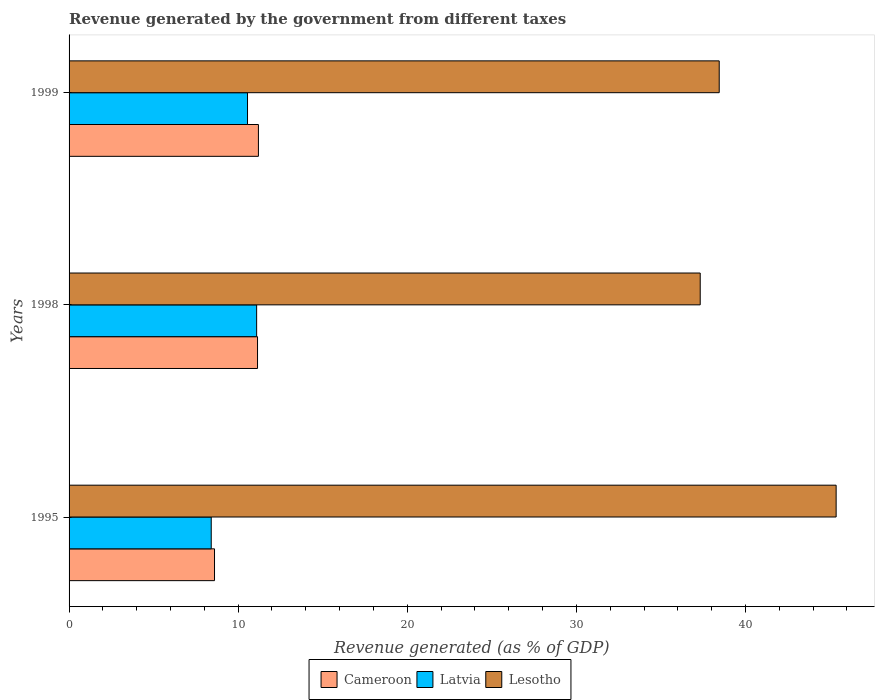How many groups of bars are there?
Keep it short and to the point. 3. Are the number of bars per tick equal to the number of legend labels?
Provide a succinct answer. Yes. Are the number of bars on each tick of the Y-axis equal?
Provide a short and direct response. Yes. How many bars are there on the 2nd tick from the bottom?
Ensure brevity in your answer.  3. What is the label of the 3rd group of bars from the top?
Provide a short and direct response. 1995. In how many cases, is the number of bars for a given year not equal to the number of legend labels?
Give a very brief answer. 0. What is the revenue generated by the government in Latvia in 1998?
Your answer should be compact. 11.09. Across all years, what is the maximum revenue generated by the government in Lesotho?
Keep it short and to the point. 45.36. Across all years, what is the minimum revenue generated by the government in Lesotho?
Offer a very short reply. 37.32. What is the total revenue generated by the government in Cameroon in the graph?
Make the answer very short. 30.94. What is the difference between the revenue generated by the government in Latvia in 1995 and that in 1998?
Your response must be concise. -2.69. What is the difference between the revenue generated by the government in Cameroon in 1995 and the revenue generated by the government in Latvia in 1999?
Provide a succinct answer. -1.95. What is the average revenue generated by the government in Lesotho per year?
Provide a succinct answer. 40.38. In the year 1995, what is the difference between the revenue generated by the government in Cameroon and revenue generated by the government in Lesotho?
Offer a terse response. -36.76. What is the ratio of the revenue generated by the government in Latvia in 1998 to that in 1999?
Your answer should be very brief. 1.05. Is the difference between the revenue generated by the government in Cameroon in 1995 and 1999 greater than the difference between the revenue generated by the government in Lesotho in 1995 and 1999?
Your response must be concise. No. What is the difference between the highest and the second highest revenue generated by the government in Latvia?
Provide a short and direct response. 0.54. What is the difference between the highest and the lowest revenue generated by the government in Latvia?
Keep it short and to the point. 2.69. In how many years, is the revenue generated by the government in Latvia greater than the average revenue generated by the government in Latvia taken over all years?
Provide a short and direct response. 2. Is the sum of the revenue generated by the government in Lesotho in 1995 and 1998 greater than the maximum revenue generated by the government in Latvia across all years?
Keep it short and to the point. Yes. What does the 1st bar from the top in 1998 represents?
Give a very brief answer. Lesotho. What does the 3rd bar from the bottom in 1995 represents?
Your answer should be very brief. Lesotho. How many bars are there?
Ensure brevity in your answer.  9. Are the values on the major ticks of X-axis written in scientific E-notation?
Your answer should be very brief. No. Does the graph contain grids?
Keep it short and to the point. No. Where does the legend appear in the graph?
Your answer should be very brief. Bottom center. How many legend labels are there?
Provide a short and direct response. 3. How are the legend labels stacked?
Provide a succinct answer. Horizontal. What is the title of the graph?
Offer a terse response. Revenue generated by the government from different taxes. Does "Sub-Saharan Africa (all income levels)" appear as one of the legend labels in the graph?
Offer a very short reply. No. What is the label or title of the X-axis?
Give a very brief answer. Revenue generated (as % of GDP). What is the Revenue generated (as % of GDP) in Cameroon in 1995?
Your answer should be very brief. 8.6. What is the Revenue generated (as % of GDP) in Latvia in 1995?
Provide a short and direct response. 8.41. What is the Revenue generated (as % of GDP) in Lesotho in 1995?
Your response must be concise. 45.36. What is the Revenue generated (as % of GDP) in Cameroon in 1998?
Your response must be concise. 11.15. What is the Revenue generated (as % of GDP) in Latvia in 1998?
Give a very brief answer. 11.09. What is the Revenue generated (as % of GDP) in Lesotho in 1998?
Your answer should be compact. 37.32. What is the Revenue generated (as % of GDP) in Cameroon in 1999?
Make the answer very short. 11.2. What is the Revenue generated (as % of GDP) of Latvia in 1999?
Ensure brevity in your answer.  10.55. What is the Revenue generated (as % of GDP) of Lesotho in 1999?
Keep it short and to the point. 38.45. Across all years, what is the maximum Revenue generated (as % of GDP) in Cameroon?
Offer a very short reply. 11.2. Across all years, what is the maximum Revenue generated (as % of GDP) in Latvia?
Give a very brief answer. 11.09. Across all years, what is the maximum Revenue generated (as % of GDP) in Lesotho?
Keep it short and to the point. 45.36. Across all years, what is the minimum Revenue generated (as % of GDP) in Cameroon?
Your answer should be compact. 8.6. Across all years, what is the minimum Revenue generated (as % of GDP) of Latvia?
Provide a short and direct response. 8.41. Across all years, what is the minimum Revenue generated (as % of GDP) in Lesotho?
Your answer should be compact. 37.32. What is the total Revenue generated (as % of GDP) of Cameroon in the graph?
Your answer should be compact. 30.94. What is the total Revenue generated (as % of GDP) in Latvia in the graph?
Provide a short and direct response. 30.05. What is the total Revenue generated (as % of GDP) of Lesotho in the graph?
Provide a succinct answer. 121.14. What is the difference between the Revenue generated (as % of GDP) in Cameroon in 1995 and that in 1998?
Offer a terse response. -2.54. What is the difference between the Revenue generated (as % of GDP) of Latvia in 1995 and that in 1998?
Ensure brevity in your answer.  -2.69. What is the difference between the Revenue generated (as % of GDP) in Lesotho in 1995 and that in 1998?
Keep it short and to the point. 8.04. What is the difference between the Revenue generated (as % of GDP) of Cameroon in 1995 and that in 1999?
Your answer should be very brief. -2.6. What is the difference between the Revenue generated (as % of GDP) of Latvia in 1995 and that in 1999?
Make the answer very short. -2.15. What is the difference between the Revenue generated (as % of GDP) of Lesotho in 1995 and that in 1999?
Your answer should be compact. 6.91. What is the difference between the Revenue generated (as % of GDP) of Cameroon in 1998 and that in 1999?
Your response must be concise. -0.05. What is the difference between the Revenue generated (as % of GDP) of Latvia in 1998 and that in 1999?
Make the answer very short. 0.54. What is the difference between the Revenue generated (as % of GDP) in Lesotho in 1998 and that in 1999?
Keep it short and to the point. -1.12. What is the difference between the Revenue generated (as % of GDP) of Cameroon in 1995 and the Revenue generated (as % of GDP) of Latvia in 1998?
Ensure brevity in your answer.  -2.49. What is the difference between the Revenue generated (as % of GDP) of Cameroon in 1995 and the Revenue generated (as % of GDP) of Lesotho in 1998?
Provide a short and direct response. -28.72. What is the difference between the Revenue generated (as % of GDP) of Latvia in 1995 and the Revenue generated (as % of GDP) of Lesotho in 1998?
Ensure brevity in your answer.  -28.92. What is the difference between the Revenue generated (as % of GDP) in Cameroon in 1995 and the Revenue generated (as % of GDP) in Latvia in 1999?
Make the answer very short. -1.95. What is the difference between the Revenue generated (as % of GDP) in Cameroon in 1995 and the Revenue generated (as % of GDP) in Lesotho in 1999?
Ensure brevity in your answer.  -29.85. What is the difference between the Revenue generated (as % of GDP) in Latvia in 1995 and the Revenue generated (as % of GDP) in Lesotho in 1999?
Your answer should be compact. -30.04. What is the difference between the Revenue generated (as % of GDP) in Cameroon in 1998 and the Revenue generated (as % of GDP) in Latvia in 1999?
Provide a short and direct response. 0.59. What is the difference between the Revenue generated (as % of GDP) in Cameroon in 1998 and the Revenue generated (as % of GDP) in Lesotho in 1999?
Your answer should be compact. -27.3. What is the difference between the Revenue generated (as % of GDP) of Latvia in 1998 and the Revenue generated (as % of GDP) of Lesotho in 1999?
Provide a succinct answer. -27.36. What is the average Revenue generated (as % of GDP) in Cameroon per year?
Make the answer very short. 10.31. What is the average Revenue generated (as % of GDP) in Latvia per year?
Make the answer very short. 10.02. What is the average Revenue generated (as % of GDP) of Lesotho per year?
Ensure brevity in your answer.  40.38. In the year 1995, what is the difference between the Revenue generated (as % of GDP) in Cameroon and Revenue generated (as % of GDP) in Latvia?
Provide a succinct answer. 0.19. In the year 1995, what is the difference between the Revenue generated (as % of GDP) in Cameroon and Revenue generated (as % of GDP) in Lesotho?
Provide a succinct answer. -36.76. In the year 1995, what is the difference between the Revenue generated (as % of GDP) in Latvia and Revenue generated (as % of GDP) in Lesotho?
Your answer should be compact. -36.96. In the year 1998, what is the difference between the Revenue generated (as % of GDP) in Cameroon and Revenue generated (as % of GDP) in Latvia?
Make the answer very short. 0.05. In the year 1998, what is the difference between the Revenue generated (as % of GDP) of Cameroon and Revenue generated (as % of GDP) of Lesotho?
Give a very brief answer. -26.18. In the year 1998, what is the difference between the Revenue generated (as % of GDP) of Latvia and Revenue generated (as % of GDP) of Lesotho?
Provide a succinct answer. -26.23. In the year 1999, what is the difference between the Revenue generated (as % of GDP) of Cameroon and Revenue generated (as % of GDP) of Latvia?
Keep it short and to the point. 0.65. In the year 1999, what is the difference between the Revenue generated (as % of GDP) of Cameroon and Revenue generated (as % of GDP) of Lesotho?
Your answer should be very brief. -27.25. In the year 1999, what is the difference between the Revenue generated (as % of GDP) of Latvia and Revenue generated (as % of GDP) of Lesotho?
Your answer should be very brief. -27.9. What is the ratio of the Revenue generated (as % of GDP) of Cameroon in 1995 to that in 1998?
Keep it short and to the point. 0.77. What is the ratio of the Revenue generated (as % of GDP) in Latvia in 1995 to that in 1998?
Provide a succinct answer. 0.76. What is the ratio of the Revenue generated (as % of GDP) in Lesotho in 1995 to that in 1998?
Your answer should be compact. 1.22. What is the ratio of the Revenue generated (as % of GDP) in Cameroon in 1995 to that in 1999?
Offer a terse response. 0.77. What is the ratio of the Revenue generated (as % of GDP) of Latvia in 1995 to that in 1999?
Provide a succinct answer. 0.8. What is the ratio of the Revenue generated (as % of GDP) in Lesotho in 1995 to that in 1999?
Your answer should be very brief. 1.18. What is the ratio of the Revenue generated (as % of GDP) in Latvia in 1998 to that in 1999?
Your answer should be very brief. 1.05. What is the ratio of the Revenue generated (as % of GDP) in Lesotho in 1998 to that in 1999?
Your answer should be compact. 0.97. What is the difference between the highest and the second highest Revenue generated (as % of GDP) of Cameroon?
Ensure brevity in your answer.  0.05. What is the difference between the highest and the second highest Revenue generated (as % of GDP) in Latvia?
Provide a short and direct response. 0.54. What is the difference between the highest and the second highest Revenue generated (as % of GDP) in Lesotho?
Offer a very short reply. 6.91. What is the difference between the highest and the lowest Revenue generated (as % of GDP) in Cameroon?
Ensure brevity in your answer.  2.6. What is the difference between the highest and the lowest Revenue generated (as % of GDP) of Latvia?
Make the answer very short. 2.69. What is the difference between the highest and the lowest Revenue generated (as % of GDP) of Lesotho?
Give a very brief answer. 8.04. 